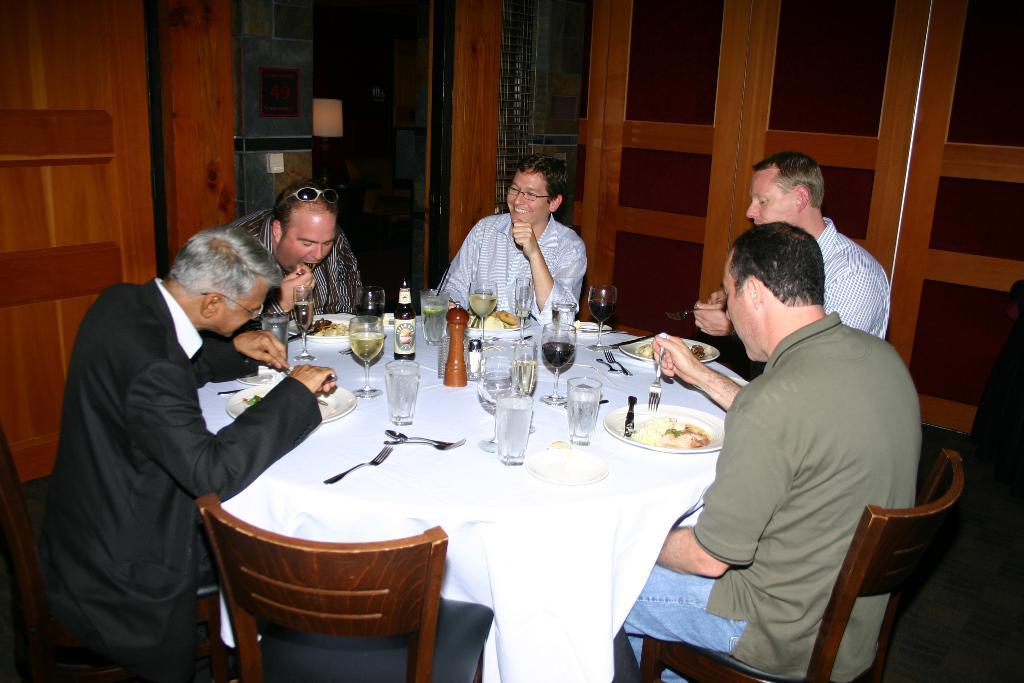How many men are present in the image? There are 5 men in the image. What are the men doing in the image? The men are sitting on chairs. What is located in front of the men? There is a table in front of the men. What items can be seen on the table? There are glasses, plates, and food on the table. What type of whip can be seen on the ground in the image? There is no whip present on the ground in the image. What kind of door is visible in the image? There is no door visible in the image. 